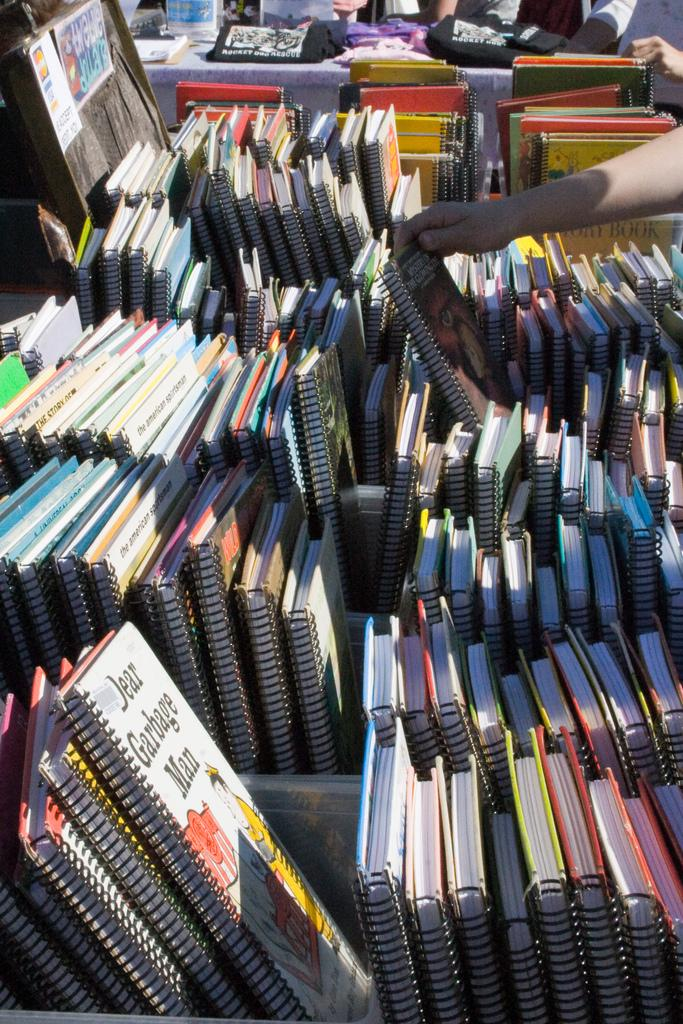What type of items can be seen in the image? There is a group of books and posters in the image. What are the people in the image doing with the books? The people in the image are holding books. What can be seen in the background of the image? There are objects visible in the background of the image. Can you tell me how many squirrels are sitting on the books in the image? There are no squirrels present in the image; it features a group of books, posters, and people holding books. What type of stretching exercise are the people in the image performing? The people in the image are not performing any stretching exercises; they are holding books. 